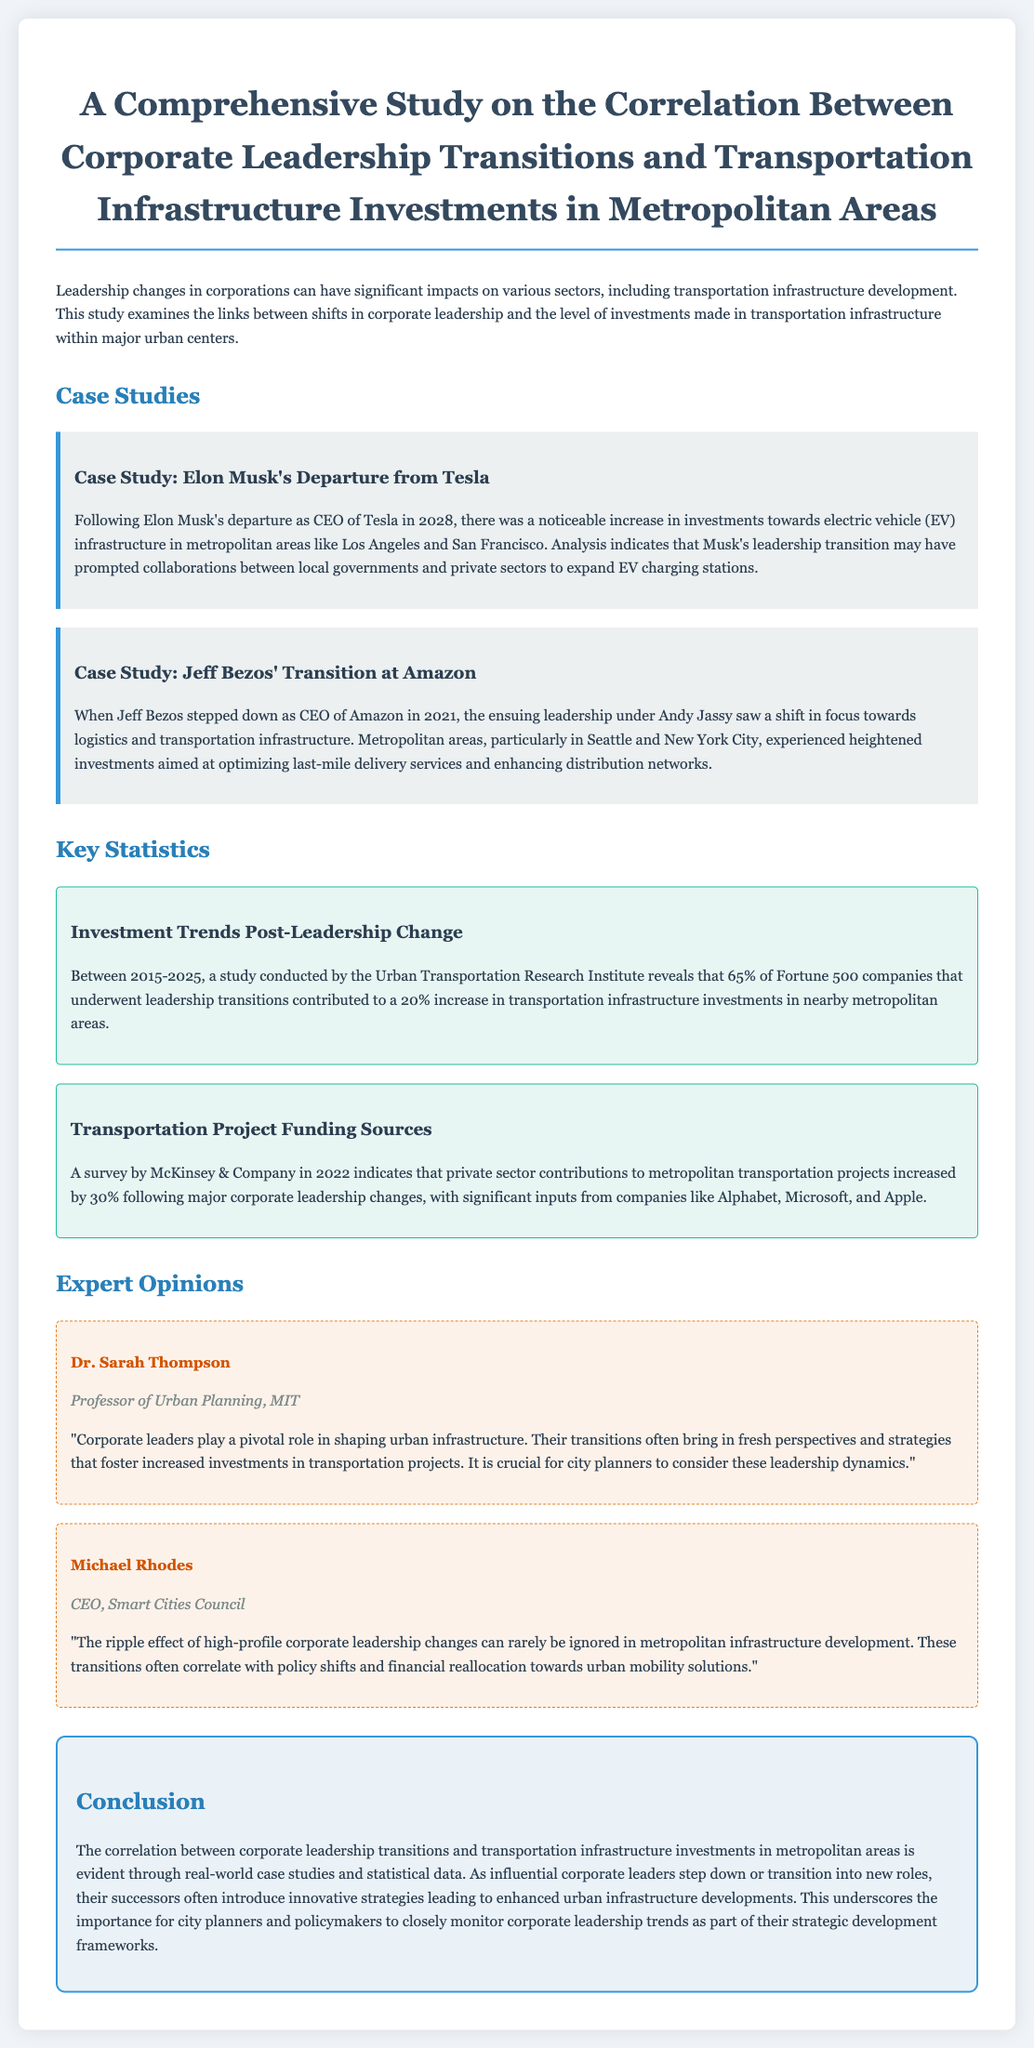What was the year of Elon Musk's departure from Tesla? The document states that Elon Musk's departure occurred in 2028.
Answer: 2028 What cities saw increased EV infrastructure investment after Musk's departure? The document mentions Los Angeles and San Francisco as cities with increased investments.
Answer: Los Angeles and San Francisco What percentage of Fortune 500 companies contributed to increased transportation infrastructure investments post-leadership change? The document indicates that 65% of these companies contributed to increased investments.
Answer: 65% Who took over as CEO of Amazon after Jeff Bezos? The document states that Andy Jassy succeeded Jeff Bezos as CEO.
Answer: Andy Jassy What was the increase in private sector contributions to transportation projects following leadership changes? According to the document, private sector contributions increased by 30%.
Answer: 30% How does Dr. Sarah Thompson describe the role of corporate leaders in urban infrastructure? Dr. Thompson asserts that corporate leaders play a pivotal role in shaping urban infrastructure.
Answer: Pivotal role What effect do corporate leadership transitions have on policy shifts in metropolitan areas? The document quotes Michael Rhodes, who suggests that these transitions often correlate with policy shifts.
Answer: Correlate with policy shifts What is the main conclusion of the study? The study concludes that corporate leadership transitions lead to enhanced urban infrastructure developments.
Answer: Enhanced urban infrastructure developments 